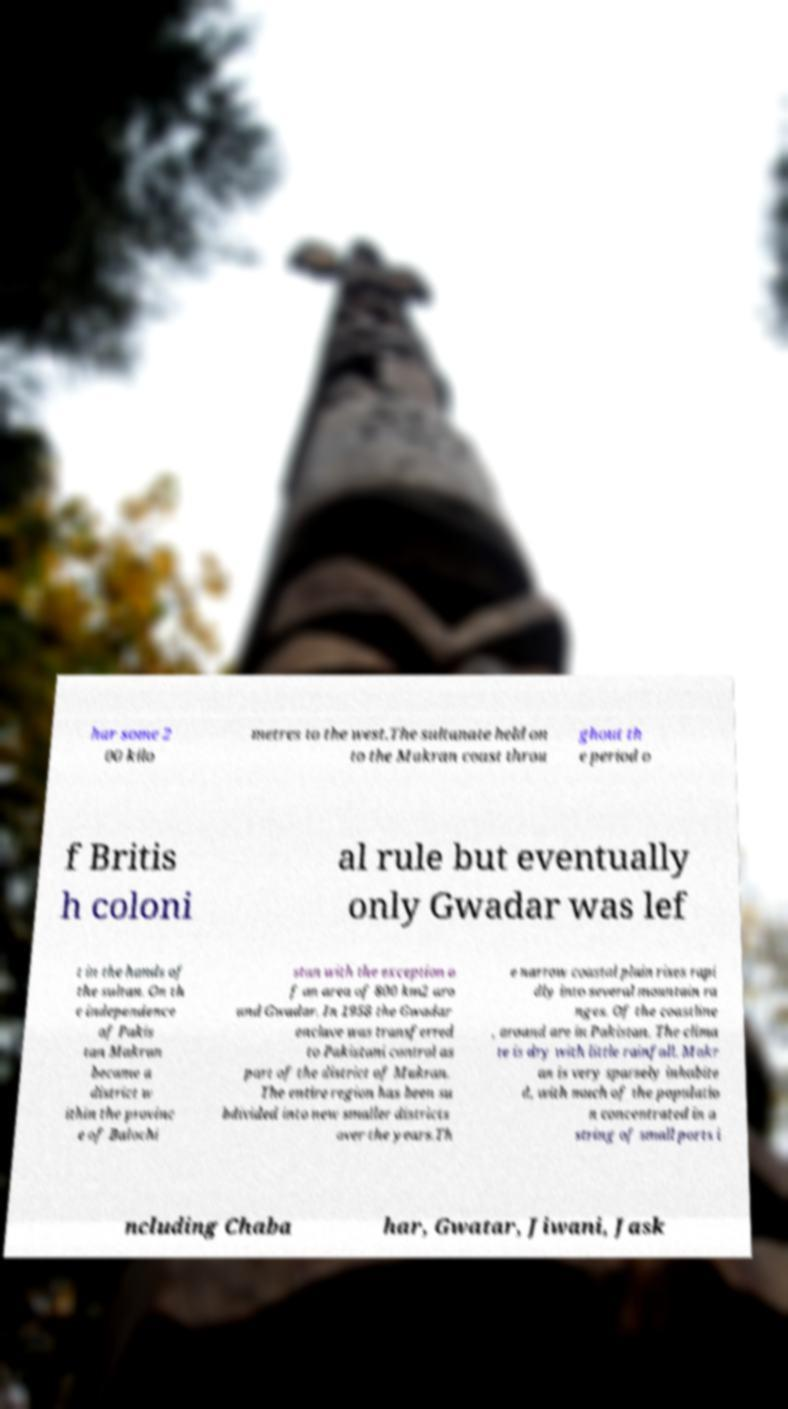What messages or text are displayed in this image? I need them in a readable, typed format. har some 2 00 kilo metres to the west.The sultanate held on to the Makran coast throu ghout th e period o f Britis h coloni al rule but eventually only Gwadar was lef t in the hands of the sultan. On th e independence of Pakis tan Makran became a district w ithin the provinc e of Balochi stan with the exception o f an area of 800 km2 aro und Gwadar. In 1958 the Gwadar enclave was transferred to Pakistani control as part of the district of Makran. The entire region has been su bdivided into new smaller districts over the years.Th e narrow coastal plain rises rapi dly into several mountain ra nges. Of the coastline , around are in Pakistan. The clima te is dry with little rainfall. Makr an is very sparsely inhabite d, with much of the populatio n concentrated in a string of small ports i ncluding Chaba har, Gwatar, Jiwani, Jask 